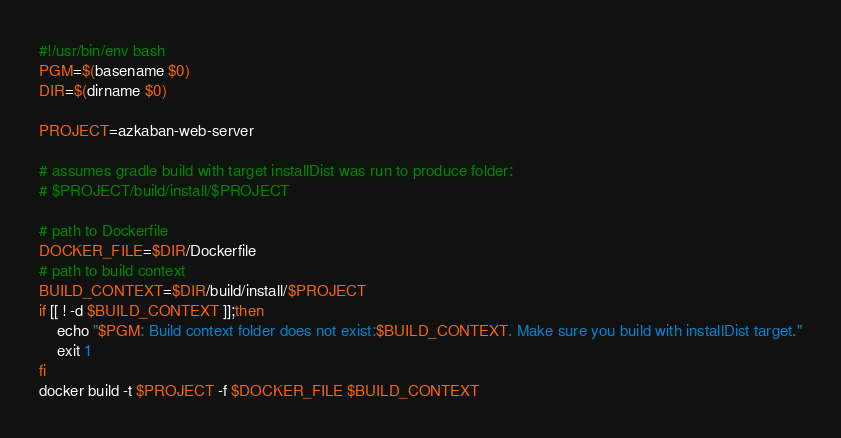Convert code to text. <code><loc_0><loc_0><loc_500><loc_500><_Bash_>#!/usr/bin/env bash
PGM=$(basename $0)
DIR=$(dirname $0)

PROJECT=azkaban-web-server

# assumes gradle build with target installDist was run to produce folder:
# $PROJECT/build/install/$PROJECT

# path to Dockerfile
DOCKER_FILE=$DIR/Dockerfile
# path to build context
BUILD_CONTEXT=$DIR/build/install/$PROJECT
if [[ ! -d $BUILD_CONTEXT ]];then
    echo "$PGM: Build context folder does not exist:$BUILD_CONTEXT. Make sure you build with installDist target."
    exit 1
fi
docker build -t $PROJECT -f $DOCKER_FILE $BUILD_CONTEXT</code> 